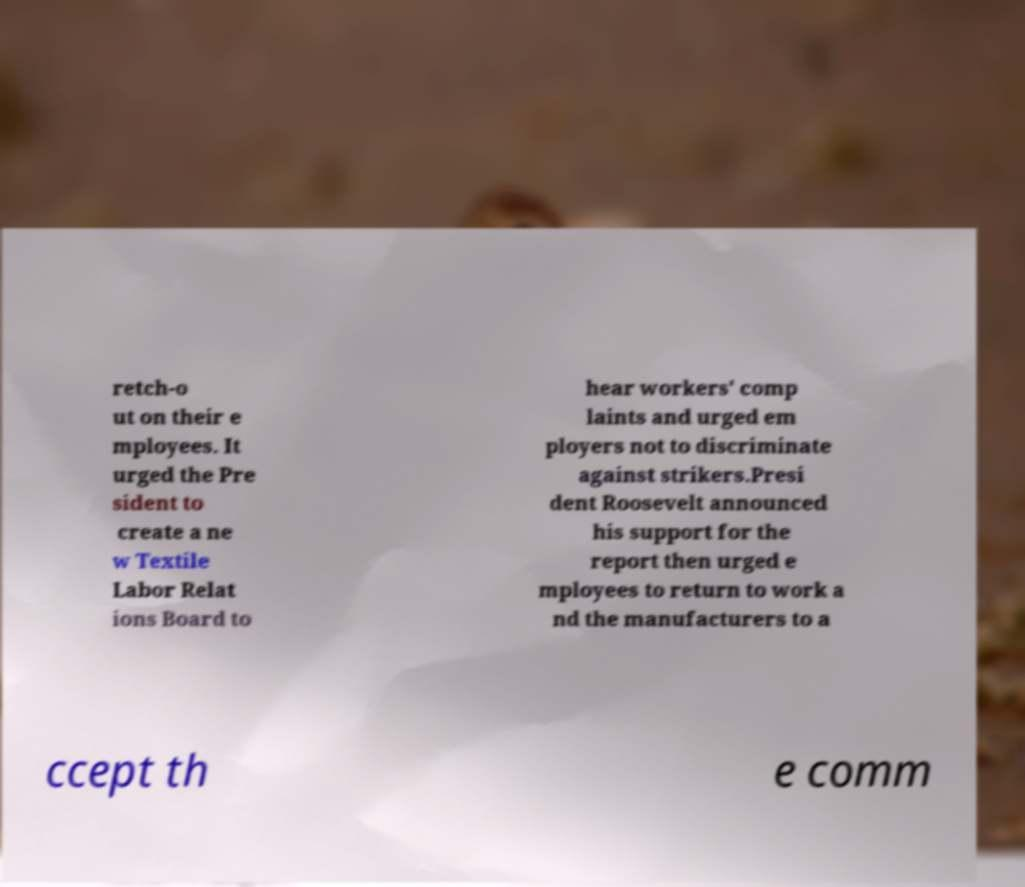Could you assist in decoding the text presented in this image and type it out clearly? retch-o ut on their e mployees. It urged the Pre sident to create a ne w Textile Labor Relat ions Board to hear workers' comp laints and urged em ployers not to discriminate against strikers.Presi dent Roosevelt announced his support for the report then urged e mployees to return to work a nd the manufacturers to a ccept th e comm 